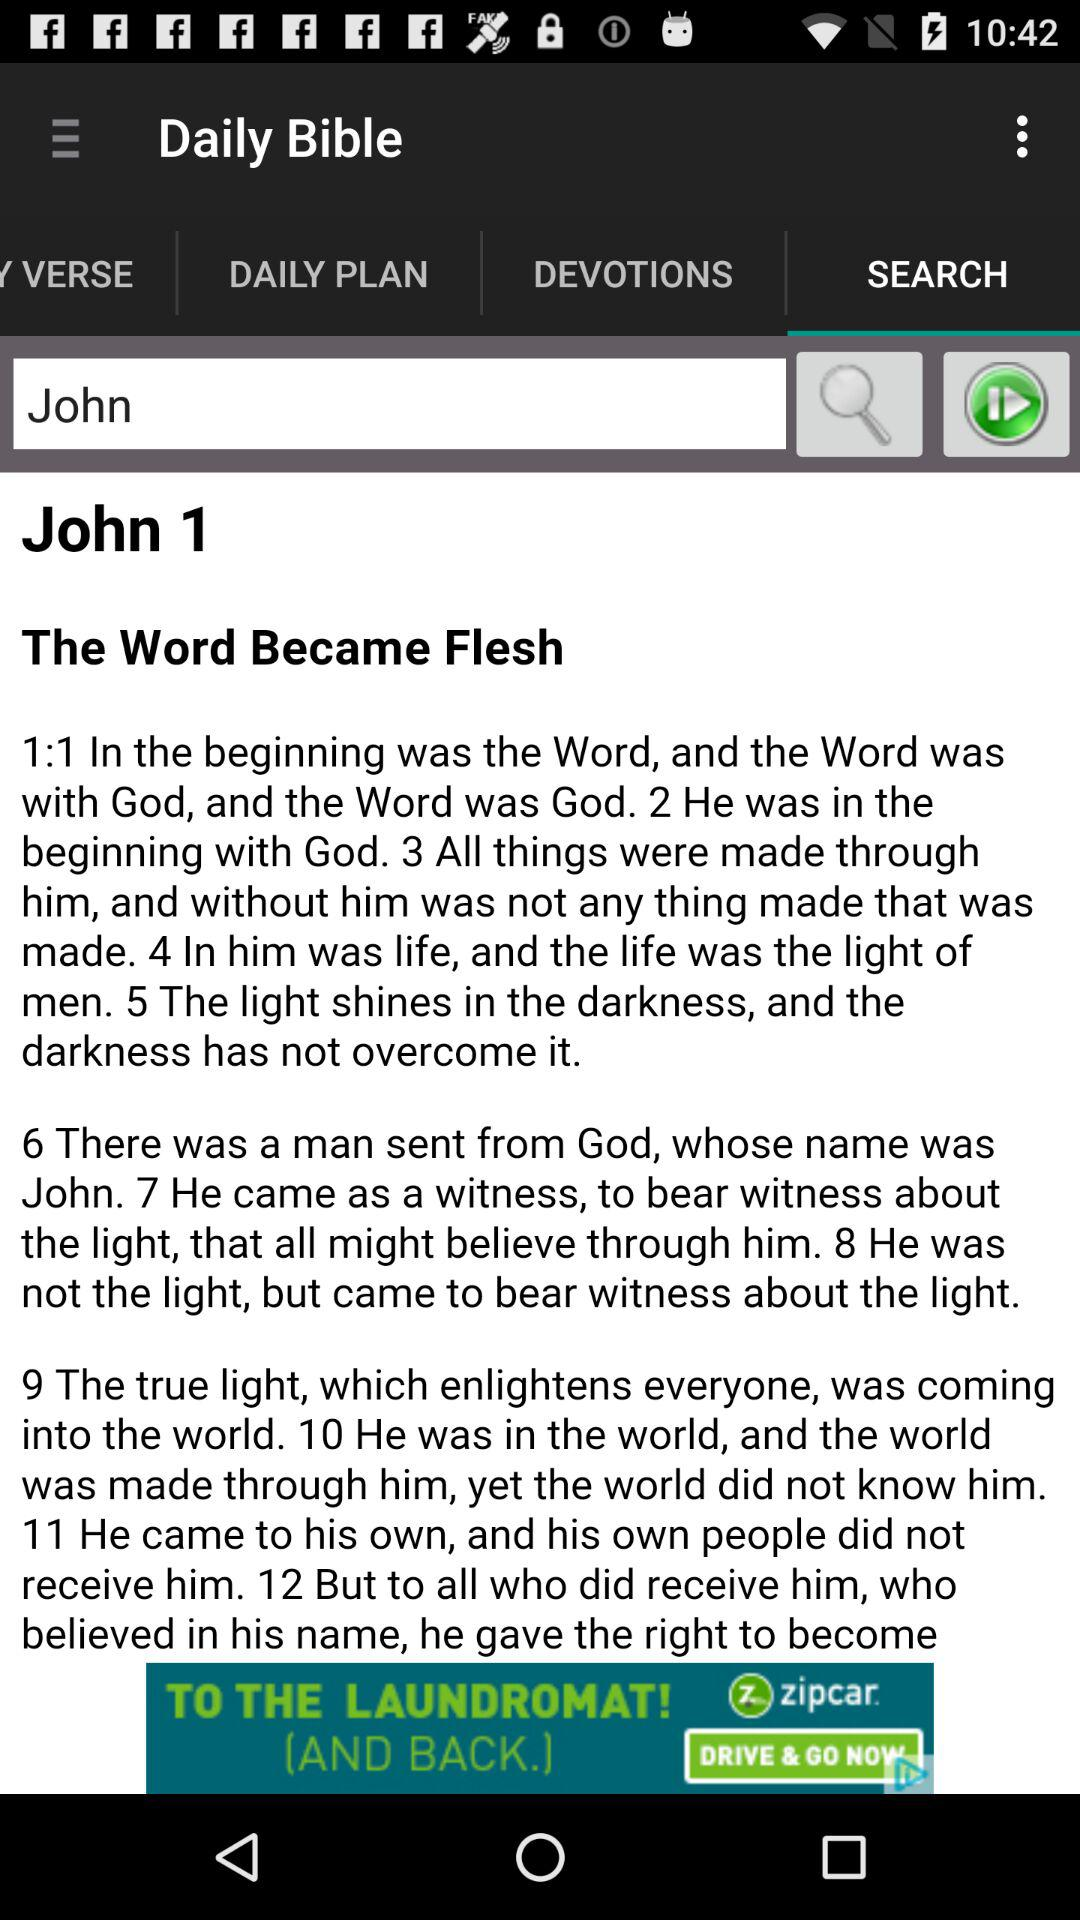What is the text in the input bar? The text in the input bar is "John". 